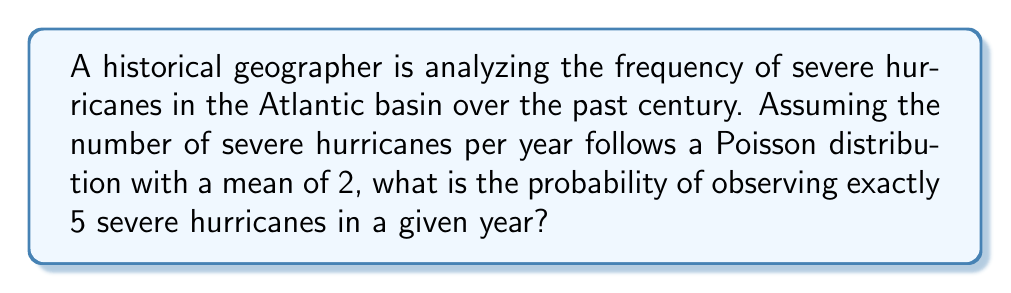Could you help me with this problem? To solve this problem, we'll use the Poisson probability mass function:

$$P(X = k) = \frac{e^{-\lambda}\lambda^k}{k!}$$

Where:
$\lambda$ = mean number of events per interval (in this case, per year)
$k$ = number of events we're interested in
$e$ = Euler's number (approximately 2.71828)

Given:
$\lambda = 2$ (mean number of severe hurricanes per year)
$k = 5$ (we're interested in the probability of exactly 5 hurricanes)

Step 1: Substitute the values into the Poisson probability mass function:

$$P(X = 5) = \frac{e^{-2}2^5}{5!}$$

Step 2: Calculate $2^5$:
$$\frac{e^{-2}32}{5!}$$

Step 3: Calculate 5!:
$$\frac{e^{-2}32}{120}$$

Step 4: Simplify:
$$\frac{e^{-2}4}{15}$$

Step 5: Calculate $e^{-2}$ (you can use a calculator for this):
$$\frac{0.1353 \times 4}{15}$$

Step 6: Multiply and divide:
$$0.0361$$

Therefore, the probability of observing exactly 5 severe hurricanes in a given year, assuming a Poisson distribution with a mean of 2, is approximately 0.0361 or 3.61%.
Answer: 0.0361 